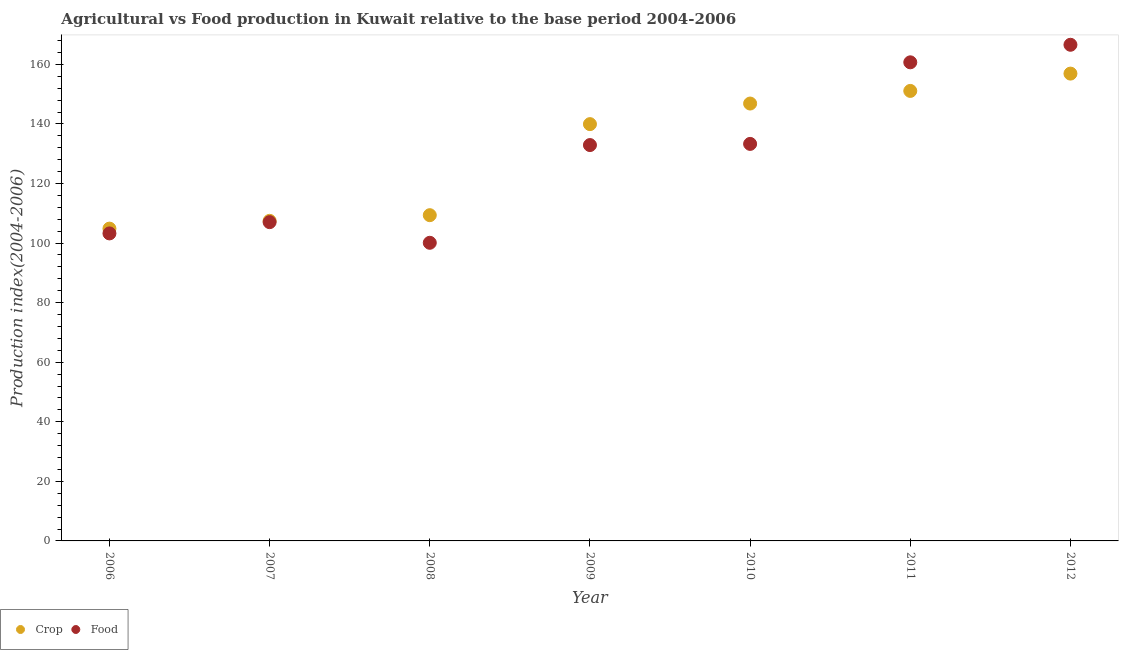What is the food production index in 2006?
Provide a short and direct response. 103.24. Across all years, what is the maximum crop production index?
Your response must be concise. 156.89. Across all years, what is the minimum food production index?
Provide a short and direct response. 100.09. In which year was the food production index maximum?
Give a very brief answer. 2012. What is the total food production index in the graph?
Offer a terse response. 903.79. What is the difference between the food production index in 2008 and that in 2012?
Give a very brief answer. -66.48. What is the difference between the food production index in 2012 and the crop production index in 2009?
Offer a terse response. 26.64. What is the average crop production index per year?
Your response must be concise. 130.92. In the year 2012, what is the difference between the crop production index and food production index?
Offer a terse response. -9.68. In how many years, is the crop production index greater than 92?
Give a very brief answer. 7. What is the ratio of the food production index in 2007 to that in 2008?
Offer a very short reply. 1.07. Is the food production index in 2008 less than that in 2009?
Offer a terse response. Yes. Is the difference between the food production index in 2008 and 2010 greater than the difference between the crop production index in 2008 and 2010?
Offer a terse response. Yes. What is the difference between the highest and the second highest food production index?
Provide a succinct answer. 5.89. What is the difference between the highest and the lowest food production index?
Keep it short and to the point. 66.48. Does the crop production index monotonically increase over the years?
Your answer should be compact. Yes. Is the food production index strictly greater than the crop production index over the years?
Ensure brevity in your answer.  No. Is the food production index strictly less than the crop production index over the years?
Offer a very short reply. No. How many dotlines are there?
Keep it short and to the point. 2. What is the difference between two consecutive major ticks on the Y-axis?
Your answer should be compact. 20. Does the graph contain any zero values?
Give a very brief answer. No. Where does the legend appear in the graph?
Provide a short and direct response. Bottom left. What is the title of the graph?
Give a very brief answer. Agricultural vs Food production in Kuwait relative to the base period 2004-2006. What is the label or title of the X-axis?
Offer a terse response. Year. What is the label or title of the Y-axis?
Ensure brevity in your answer.  Production index(2004-2006). What is the Production index(2004-2006) of Crop in 2006?
Keep it short and to the point. 104.85. What is the Production index(2004-2006) of Food in 2006?
Offer a terse response. 103.24. What is the Production index(2004-2006) of Crop in 2007?
Your answer should be compact. 107.46. What is the Production index(2004-2006) in Food in 2007?
Offer a terse response. 107.02. What is the Production index(2004-2006) of Crop in 2008?
Offer a terse response. 109.36. What is the Production index(2004-2006) in Food in 2008?
Give a very brief answer. 100.09. What is the Production index(2004-2006) in Crop in 2009?
Offer a very short reply. 139.93. What is the Production index(2004-2006) in Food in 2009?
Give a very brief answer. 132.9. What is the Production index(2004-2006) in Crop in 2010?
Ensure brevity in your answer.  146.84. What is the Production index(2004-2006) in Food in 2010?
Ensure brevity in your answer.  133.29. What is the Production index(2004-2006) of Crop in 2011?
Provide a short and direct response. 151.08. What is the Production index(2004-2006) in Food in 2011?
Your answer should be compact. 160.68. What is the Production index(2004-2006) in Crop in 2012?
Your response must be concise. 156.89. What is the Production index(2004-2006) in Food in 2012?
Offer a terse response. 166.57. Across all years, what is the maximum Production index(2004-2006) in Crop?
Offer a very short reply. 156.89. Across all years, what is the maximum Production index(2004-2006) of Food?
Offer a terse response. 166.57. Across all years, what is the minimum Production index(2004-2006) of Crop?
Give a very brief answer. 104.85. Across all years, what is the minimum Production index(2004-2006) of Food?
Keep it short and to the point. 100.09. What is the total Production index(2004-2006) of Crop in the graph?
Your response must be concise. 916.41. What is the total Production index(2004-2006) of Food in the graph?
Ensure brevity in your answer.  903.79. What is the difference between the Production index(2004-2006) in Crop in 2006 and that in 2007?
Offer a terse response. -2.61. What is the difference between the Production index(2004-2006) in Food in 2006 and that in 2007?
Give a very brief answer. -3.78. What is the difference between the Production index(2004-2006) in Crop in 2006 and that in 2008?
Keep it short and to the point. -4.51. What is the difference between the Production index(2004-2006) of Food in 2006 and that in 2008?
Offer a very short reply. 3.15. What is the difference between the Production index(2004-2006) in Crop in 2006 and that in 2009?
Your answer should be very brief. -35.08. What is the difference between the Production index(2004-2006) of Food in 2006 and that in 2009?
Keep it short and to the point. -29.66. What is the difference between the Production index(2004-2006) of Crop in 2006 and that in 2010?
Keep it short and to the point. -41.99. What is the difference between the Production index(2004-2006) in Food in 2006 and that in 2010?
Give a very brief answer. -30.05. What is the difference between the Production index(2004-2006) in Crop in 2006 and that in 2011?
Provide a short and direct response. -46.23. What is the difference between the Production index(2004-2006) of Food in 2006 and that in 2011?
Make the answer very short. -57.44. What is the difference between the Production index(2004-2006) in Crop in 2006 and that in 2012?
Offer a very short reply. -52.04. What is the difference between the Production index(2004-2006) of Food in 2006 and that in 2012?
Your response must be concise. -63.33. What is the difference between the Production index(2004-2006) in Food in 2007 and that in 2008?
Offer a very short reply. 6.93. What is the difference between the Production index(2004-2006) of Crop in 2007 and that in 2009?
Ensure brevity in your answer.  -32.47. What is the difference between the Production index(2004-2006) of Food in 2007 and that in 2009?
Keep it short and to the point. -25.88. What is the difference between the Production index(2004-2006) of Crop in 2007 and that in 2010?
Provide a short and direct response. -39.38. What is the difference between the Production index(2004-2006) of Food in 2007 and that in 2010?
Offer a terse response. -26.27. What is the difference between the Production index(2004-2006) of Crop in 2007 and that in 2011?
Make the answer very short. -43.62. What is the difference between the Production index(2004-2006) of Food in 2007 and that in 2011?
Your answer should be very brief. -53.66. What is the difference between the Production index(2004-2006) of Crop in 2007 and that in 2012?
Ensure brevity in your answer.  -49.43. What is the difference between the Production index(2004-2006) of Food in 2007 and that in 2012?
Your answer should be compact. -59.55. What is the difference between the Production index(2004-2006) in Crop in 2008 and that in 2009?
Offer a very short reply. -30.57. What is the difference between the Production index(2004-2006) in Food in 2008 and that in 2009?
Your answer should be compact. -32.81. What is the difference between the Production index(2004-2006) in Crop in 2008 and that in 2010?
Offer a terse response. -37.48. What is the difference between the Production index(2004-2006) in Food in 2008 and that in 2010?
Provide a short and direct response. -33.2. What is the difference between the Production index(2004-2006) of Crop in 2008 and that in 2011?
Your response must be concise. -41.72. What is the difference between the Production index(2004-2006) in Food in 2008 and that in 2011?
Offer a terse response. -60.59. What is the difference between the Production index(2004-2006) in Crop in 2008 and that in 2012?
Offer a very short reply. -47.53. What is the difference between the Production index(2004-2006) of Food in 2008 and that in 2012?
Make the answer very short. -66.48. What is the difference between the Production index(2004-2006) in Crop in 2009 and that in 2010?
Offer a terse response. -6.91. What is the difference between the Production index(2004-2006) of Food in 2009 and that in 2010?
Make the answer very short. -0.39. What is the difference between the Production index(2004-2006) of Crop in 2009 and that in 2011?
Offer a terse response. -11.15. What is the difference between the Production index(2004-2006) in Food in 2009 and that in 2011?
Ensure brevity in your answer.  -27.78. What is the difference between the Production index(2004-2006) of Crop in 2009 and that in 2012?
Offer a very short reply. -16.96. What is the difference between the Production index(2004-2006) in Food in 2009 and that in 2012?
Offer a very short reply. -33.67. What is the difference between the Production index(2004-2006) of Crop in 2010 and that in 2011?
Your response must be concise. -4.24. What is the difference between the Production index(2004-2006) of Food in 2010 and that in 2011?
Keep it short and to the point. -27.39. What is the difference between the Production index(2004-2006) in Crop in 2010 and that in 2012?
Provide a short and direct response. -10.05. What is the difference between the Production index(2004-2006) in Food in 2010 and that in 2012?
Offer a very short reply. -33.28. What is the difference between the Production index(2004-2006) in Crop in 2011 and that in 2012?
Give a very brief answer. -5.81. What is the difference between the Production index(2004-2006) of Food in 2011 and that in 2012?
Your answer should be very brief. -5.89. What is the difference between the Production index(2004-2006) in Crop in 2006 and the Production index(2004-2006) in Food in 2007?
Ensure brevity in your answer.  -2.17. What is the difference between the Production index(2004-2006) of Crop in 2006 and the Production index(2004-2006) of Food in 2008?
Your answer should be compact. 4.76. What is the difference between the Production index(2004-2006) in Crop in 2006 and the Production index(2004-2006) in Food in 2009?
Offer a very short reply. -28.05. What is the difference between the Production index(2004-2006) in Crop in 2006 and the Production index(2004-2006) in Food in 2010?
Make the answer very short. -28.44. What is the difference between the Production index(2004-2006) of Crop in 2006 and the Production index(2004-2006) of Food in 2011?
Provide a short and direct response. -55.83. What is the difference between the Production index(2004-2006) in Crop in 2006 and the Production index(2004-2006) in Food in 2012?
Provide a succinct answer. -61.72. What is the difference between the Production index(2004-2006) of Crop in 2007 and the Production index(2004-2006) of Food in 2008?
Offer a terse response. 7.37. What is the difference between the Production index(2004-2006) of Crop in 2007 and the Production index(2004-2006) of Food in 2009?
Offer a terse response. -25.44. What is the difference between the Production index(2004-2006) in Crop in 2007 and the Production index(2004-2006) in Food in 2010?
Offer a terse response. -25.83. What is the difference between the Production index(2004-2006) in Crop in 2007 and the Production index(2004-2006) in Food in 2011?
Give a very brief answer. -53.22. What is the difference between the Production index(2004-2006) of Crop in 2007 and the Production index(2004-2006) of Food in 2012?
Provide a succinct answer. -59.11. What is the difference between the Production index(2004-2006) of Crop in 2008 and the Production index(2004-2006) of Food in 2009?
Ensure brevity in your answer.  -23.54. What is the difference between the Production index(2004-2006) of Crop in 2008 and the Production index(2004-2006) of Food in 2010?
Your response must be concise. -23.93. What is the difference between the Production index(2004-2006) in Crop in 2008 and the Production index(2004-2006) in Food in 2011?
Offer a very short reply. -51.32. What is the difference between the Production index(2004-2006) of Crop in 2008 and the Production index(2004-2006) of Food in 2012?
Ensure brevity in your answer.  -57.21. What is the difference between the Production index(2004-2006) in Crop in 2009 and the Production index(2004-2006) in Food in 2010?
Offer a terse response. 6.64. What is the difference between the Production index(2004-2006) in Crop in 2009 and the Production index(2004-2006) in Food in 2011?
Offer a terse response. -20.75. What is the difference between the Production index(2004-2006) in Crop in 2009 and the Production index(2004-2006) in Food in 2012?
Keep it short and to the point. -26.64. What is the difference between the Production index(2004-2006) in Crop in 2010 and the Production index(2004-2006) in Food in 2011?
Your response must be concise. -13.84. What is the difference between the Production index(2004-2006) in Crop in 2010 and the Production index(2004-2006) in Food in 2012?
Provide a succinct answer. -19.73. What is the difference between the Production index(2004-2006) in Crop in 2011 and the Production index(2004-2006) in Food in 2012?
Keep it short and to the point. -15.49. What is the average Production index(2004-2006) of Crop per year?
Provide a short and direct response. 130.92. What is the average Production index(2004-2006) in Food per year?
Give a very brief answer. 129.11. In the year 2006, what is the difference between the Production index(2004-2006) of Crop and Production index(2004-2006) of Food?
Provide a succinct answer. 1.61. In the year 2007, what is the difference between the Production index(2004-2006) of Crop and Production index(2004-2006) of Food?
Provide a succinct answer. 0.44. In the year 2008, what is the difference between the Production index(2004-2006) in Crop and Production index(2004-2006) in Food?
Your answer should be very brief. 9.27. In the year 2009, what is the difference between the Production index(2004-2006) of Crop and Production index(2004-2006) of Food?
Provide a short and direct response. 7.03. In the year 2010, what is the difference between the Production index(2004-2006) of Crop and Production index(2004-2006) of Food?
Offer a very short reply. 13.55. In the year 2012, what is the difference between the Production index(2004-2006) of Crop and Production index(2004-2006) of Food?
Make the answer very short. -9.68. What is the ratio of the Production index(2004-2006) in Crop in 2006 to that in 2007?
Offer a very short reply. 0.98. What is the ratio of the Production index(2004-2006) of Food in 2006 to that in 2007?
Provide a succinct answer. 0.96. What is the ratio of the Production index(2004-2006) in Crop in 2006 to that in 2008?
Your response must be concise. 0.96. What is the ratio of the Production index(2004-2006) in Food in 2006 to that in 2008?
Your answer should be very brief. 1.03. What is the ratio of the Production index(2004-2006) of Crop in 2006 to that in 2009?
Your response must be concise. 0.75. What is the ratio of the Production index(2004-2006) in Food in 2006 to that in 2009?
Provide a short and direct response. 0.78. What is the ratio of the Production index(2004-2006) of Crop in 2006 to that in 2010?
Provide a succinct answer. 0.71. What is the ratio of the Production index(2004-2006) in Food in 2006 to that in 2010?
Your response must be concise. 0.77. What is the ratio of the Production index(2004-2006) of Crop in 2006 to that in 2011?
Your response must be concise. 0.69. What is the ratio of the Production index(2004-2006) in Food in 2006 to that in 2011?
Your answer should be compact. 0.64. What is the ratio of the Production index(2004-2006) in Crop in 2006 to that in 2012?
Offer a very short reply. 0.67. What is the ratio of the Production index(2004-2006) of Food in 2006 to that in 2012?
Your response must be concise. 0.62. What is the ratio of the Production index(2004-2006) in Crop in 2007 to that in 2008?
Give a very brief answer. 0.98. What is the ratio of the Production index(2004-2006) of Food in 2007 to that in 2008?
Make the answer very short. 1.07. What is the ratio of the Production index(2004-2006) of Crop in 2007 to that in 2009?
Keep it short and to the point. 0.77. What is the ratio of the Production index(2004-2006) of Food in 2007 to that in 2009?
Ensure brevity in your answer.  0.81. What is the ratio of the Production index(2004-2006) in Crop in 2007 to that in 2010?
Ensure brevity in your answer.  0.73. What is the ratio of the Production index(2004-2006) in Food in 2007 to that in 2010?
Your answer should be compact. 0.8. What is the ratio of the Production index(2004-2006) of Crop in 2007 to that in 2011?
Ensure brevity in your answer.  0.71. What is the ratio of the Production index(2004-2006) of Food in 2007 to that in 2011?
Offer a terse response. 0.67. What is the ratio of the Production index(2004-2006) of Crop in 2007 to that in 2012?
Your answer should be very brief. 0.68. What is the ratio of the Production index(2004-2006) of Food in 2007 to that in 2012?
Make the answer very short. 0.64. What is the ratio of the Production index(2004-2006) in Crop in 2008 to that in 2009?
Give a very brief answer. 0.78. What is the ratio of the Production index(2004-2006) in Food in 2008 to that in 2009?
Give a very brief answer. 0.75. What is the ratio of the Production index(2004-2006) in Crop in 2008 to that in 2010?
Keep it short and to the point. 0.74. What is the ratio of the Production index(2004-2006) of Food in 2008 to that in 2010?
Offer a terse response. 0.75. What is the ratio of the Production index(2004-2006) in Crop in 2008 to that in 2011?
Your answer should be compact. 0.72. What is the ratio of the Production index(2004-2006) of Food in 2008 to that in 2011?
Ensure brevity in your answer.  0.62. What is the ratio of the Production index(2004-2006) in Crop in 2008 to that in 2012?
Ensure brevity in your answer.  0.7. What is the ratio of the Production index(2004-2006) in Food in 2008 to that in 2012?
Ensure brevity in your answer.  0.6. What is the ratio of the Production index(2004-2006) in Crop in 2009 to that in 2010?
Provide a short and direct response. 0.95. What is the ratio of the Production index(2004-2006) in Food in 2009 to that in 2010?
Your answer should be very brief. 1. What is the ratio of the Production index(2004-2006) in Crop in 2009 to that in 2011?
Keep it short and to the point. 0.93. What is the ratio of the Production index(2004-2006) in Food in 2009 to that in 2011?
Your answer should be compact. 0.83. What is the ratio of the Production index(2004-2006) of Crop in 2009 to that in 2012?
Keep it short and to the point. 0.89. What is the ratio of the Production index(2004-2006) of Food in 2009 to that in 2012?
Ensure brevity in your answer.  0.8. What is the ratio of the Production index(2004-2006) of Crop in 2010 to that in 2011?
Offer a very short reply. 0.97. What is the ratio of the Production index(2004-2006) of Food in 2010 to that in 2011?
Provide a short and direct response. 0.83. What is the ratio of the Production index(2004-2006) of Crop in 2010 to that in 2012?
Your answer should be compact. 0.94. What is the ratio of the Production index(2004-2006) in Food in 2010 to that in 2012?
Provide a short and direct response. 0.8. What is the ratio of the Production index(2004-2006) of Food in 2011 to that in 2012?
Make the answer very short. 0.96. What is the difference between the highest and the second highest Production index(2004-2006) in Crop?
Your answer should be compact. 5.81. What is the difference between the highest and the second highest Production index(2004-2006) of Food?
Give a very brief answer. 5.89. What is the difference between the highest and the lowest Production index(2004-2006) in Crop?
Offer a very short reply. 52.04. What is the difference between the highest and the lowest Production index(2004-2006) of Food?
Your response must be concise. 66.48. 